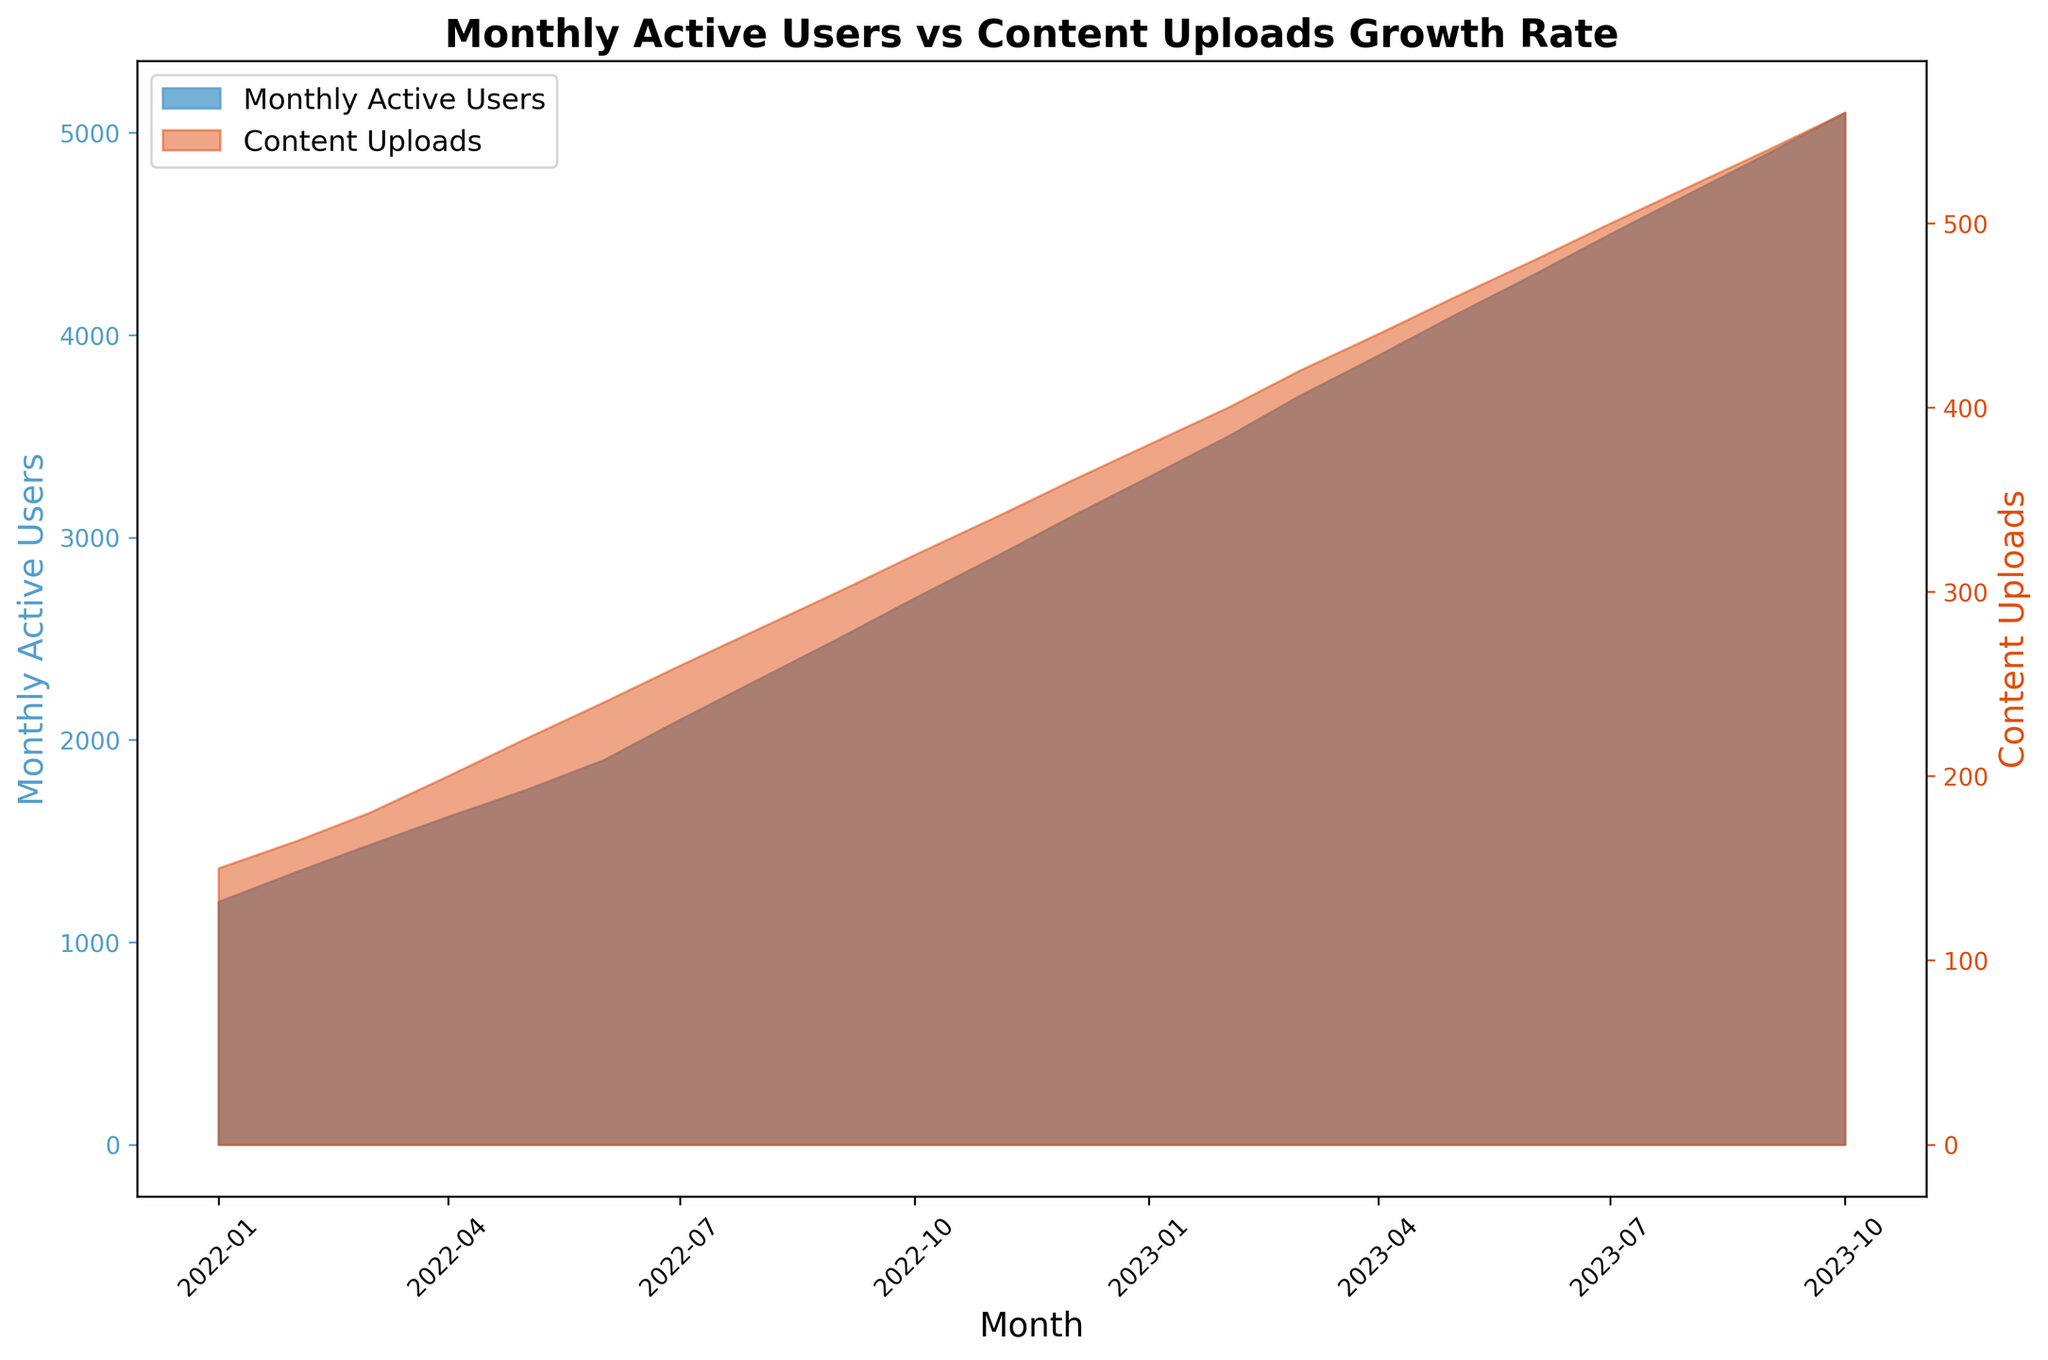What is the overall trend of Monthly Active Users from January 2022 to October 2023? The Monthly Active Users show a clear upward trend throughout the period from January 2022 to October 2023, increasing continuously each month.
Answer: Upward trend Do Monthly Active Users and Content Uploads follow a similar pattern over time? Both Monthly Active Users and Content Uploads show a continuous growth pattern over time, increasing month by month, which implies a correlated growth between the two metrics.
Answer: Yes In which month do Content Uploads first exceed 300? Referencing the chart, Content Uploads exceed 300 for the first time in September 2022.
Answer: September 2022 By how much have Content Uploads grown from January 2022 to October 2023? Content Uploads in January 2022 were 150, and by October 2023 they reached 560. The increase is 560 - 150, which is 410.
Answer: 410 What is the average number of Content Uploads in the year 2022? Content Uploads for 2022 are: 150, 165, 180, 200, 220, 240, 260, 280, 300, 320, 340, 360. Summing them gives 3215, and there are 12 months in 2022. Average = 3215 / 12 = 267.92
Answer: 267.92 Between which two consecutive months is the increase in Monthly Active Users the highest? Comparing the changes month-to-month, the highest increase in Monthly Active Users is between December 2022 (3100) and January 2023 (3300), an increase of 200 users.
Answer: December 2022 and January 2023 Which has a steeper growth rate overall, Monthly Active Users or Content Uploads? Visually, both metrics show strong growth, but Monthly Active Users have a higher absolute increase over the period. Starting at 1200 and ending at 5100, an increase of 3900, whereas Content Uploads start at 150 and reach 560, an increase of 410.
Answer: Monthly Active Users By how much do the Monthly Active Users increase every month on average? The total increase in Monthly Active Users from January 2022 (1200) to October 2023 (5100) is 5100 - 1200 = 3900 over 21 months. Average increase per month = 3900 / 21 ≈ 185.71.
Answer: 185.71 How do the colors used in the chart help in distinguishing between Monthly Active Users and Content Uploads? The Monthly Active Users are displayed with a blue shade, while Content Uploads are indicated using a red shade, making it easy to differentiate between the two metrics visually.
Answer: Blue and Red How does the growth rate of Monthly Active Users in the first half of 2022 compare to the second half? In the first half of 2022 (January to June), Monthly Active Users increased from 1200 to 1900, an increase of 700. In the second half (July to December), they increased from 2100 to 3100, an increase of 1000. Thus, the second half saw a more significant growth in users.
Answer: Second half higher 